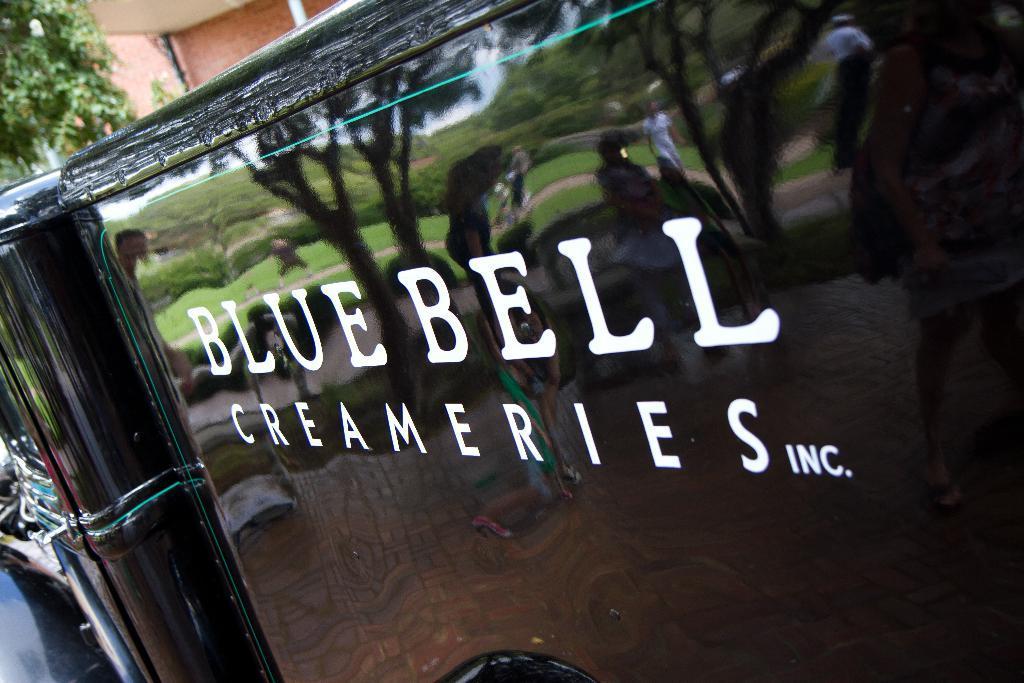Describe this image in one or two sentences. In this image there is some text on a fence, from the reflection we can see a few people standing and sitting on benches, behind them there are trees, behind the fence there are trees and buildings. 